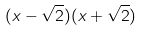<formula> <loc_0><loc_0><loc_500><loc_500>( x - \sqrt { 2 } ) ( x + \sqrt { 2 } )</formula> 